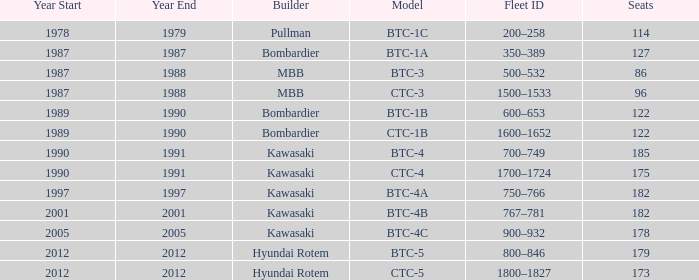Which model has 175 seats? CTC-4. 